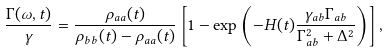Convert formula to latex. <formula><loc_0><loc_0><loc_500><loc_500>\frac { \Gamma ( \omega , t ) } { \gamma } = \frac { \rho _ { a a } ( t ) } { \rho _ { b b } ( t ) - \rho _ { a a } ( t ) } \left [ 1 - \exp \left ( - H ( t ) \frac { \gamma _ { a b } \Gamma _ { a b } } { \Gamma _ { a b } ^ { 2 } + \Delta ^ { 2 } } \right ) \right ] ,</formula> 